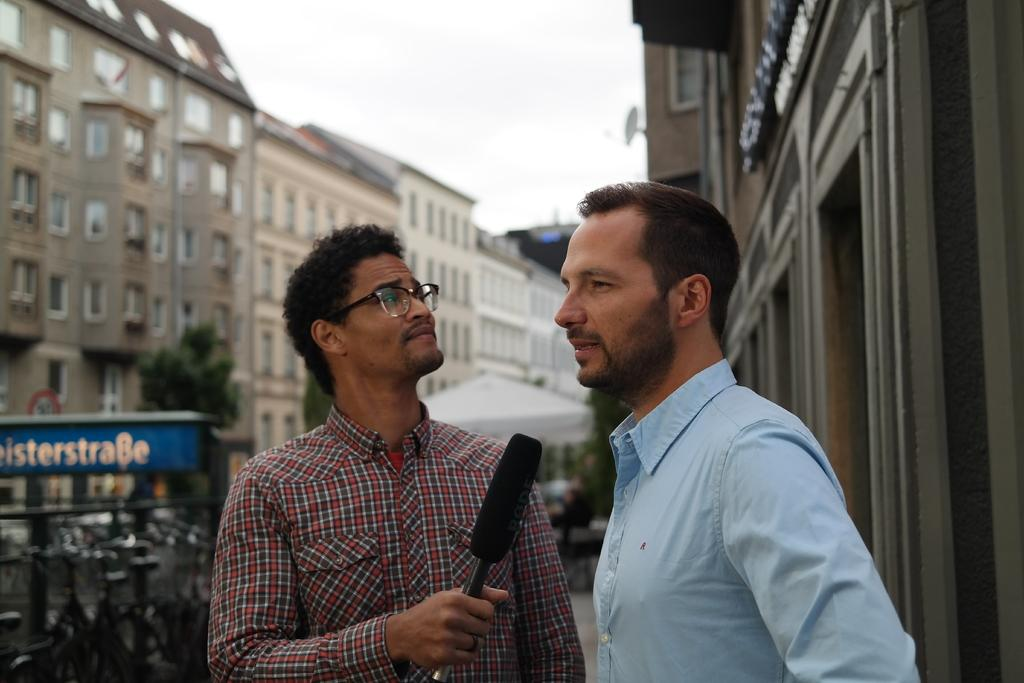How many people are in the image? There are two persons in the image. Can you describe the appearance of the person holding a mic? The person holding a mic is wearing a check shirt and goggles. What is the other person wearing? The other person is wearing a blue shirt. What is the person in the blue shirt doing? The person in the blue shirt is talking. What can be seen in the background of the image? There is a building in the background of the image. Are there any cobwebs visible in the image? There is no mention of cobwebs in the provided facts, and therefore we cannot determine their presence in the image. 